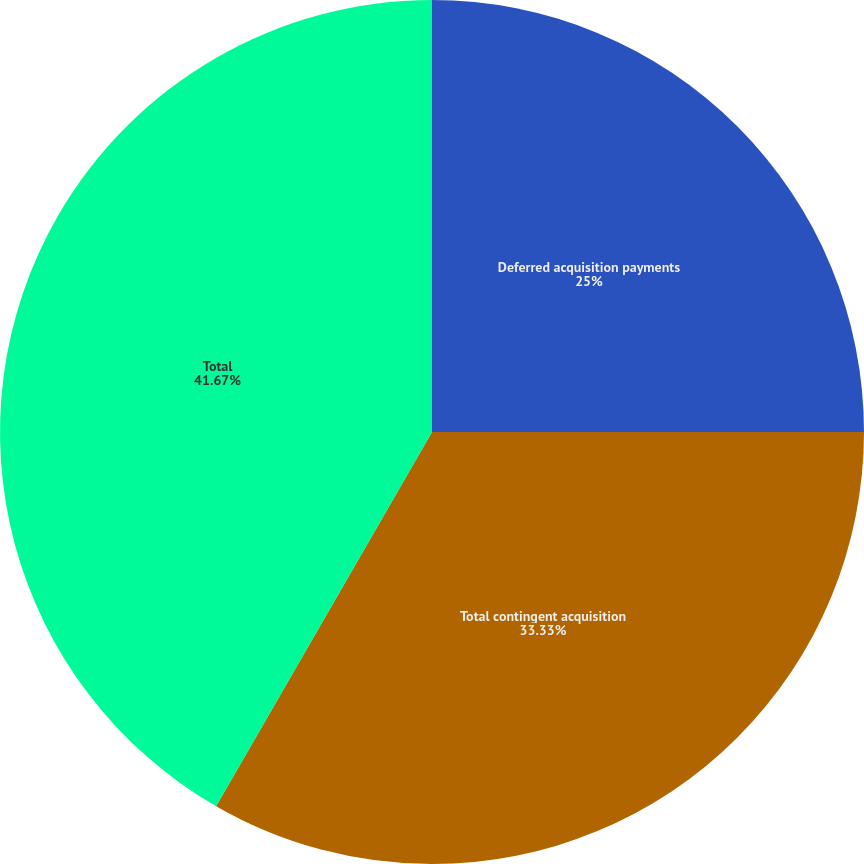Convert chart. <chart><loc_0><loc_0><loc_500><loc_500><pie_chart><fcel>Deferred acquisition payments<fcel>Total contingent acquisition<fcel>Total<nl><fcel>25.0%<fcel>33.33%<fcel>41.67%<nl></chart> 